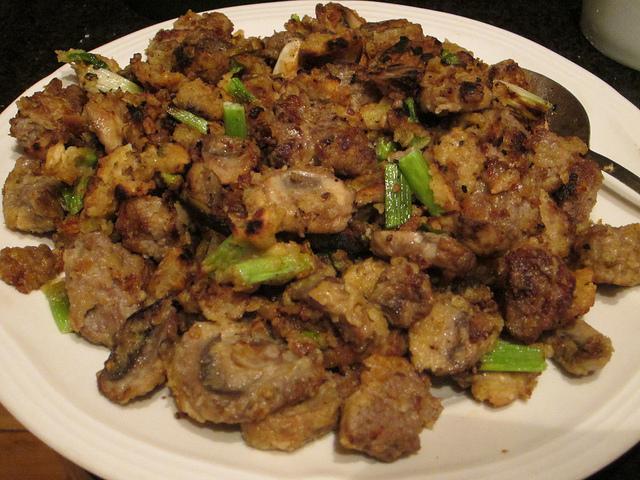Is the meal tasty?
Quick response, please. Yes. What color is the plate?
Give a very brief answer. White. How many portions are on the plate?
Quick response, please. 1. What vegetable is in the upper right corner of this photo?
Answer briefly. Mushroom. Is the food mostly brown?
Short answer required. Yes. Are there vegetables?
Write a very short answer. Yes. Is this meal healthy?
Quick response, please. No. What is green?
Answer briefly. Green onion. 